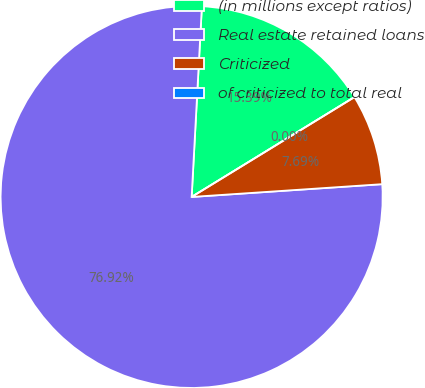Convert chart to OTSL. <chart><loc_0><loc_0><loc_500><loc_500><pie_chart><fcel>(in millions except ratios)<fcel>Real estate retained loans<fcel>Criticized<fcel>of criticized to total real<nl><fcel>15.39%<fcel>76.92%<fcel>7.69%<fcel>0.0%<nl></chart> 